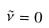Convert formula to latex. <formula><loc_0><loc_0><loc_500><loc_500>\tilde { \nu } = 0</formula> 